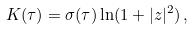<formula> <loc_0><loc_0><loc_500><loc_500>K ( \tau ) = \sigma ( \tau ) \, { \ln } ( 1 + | z | ^ { 2 } ) \, ,</formula> 